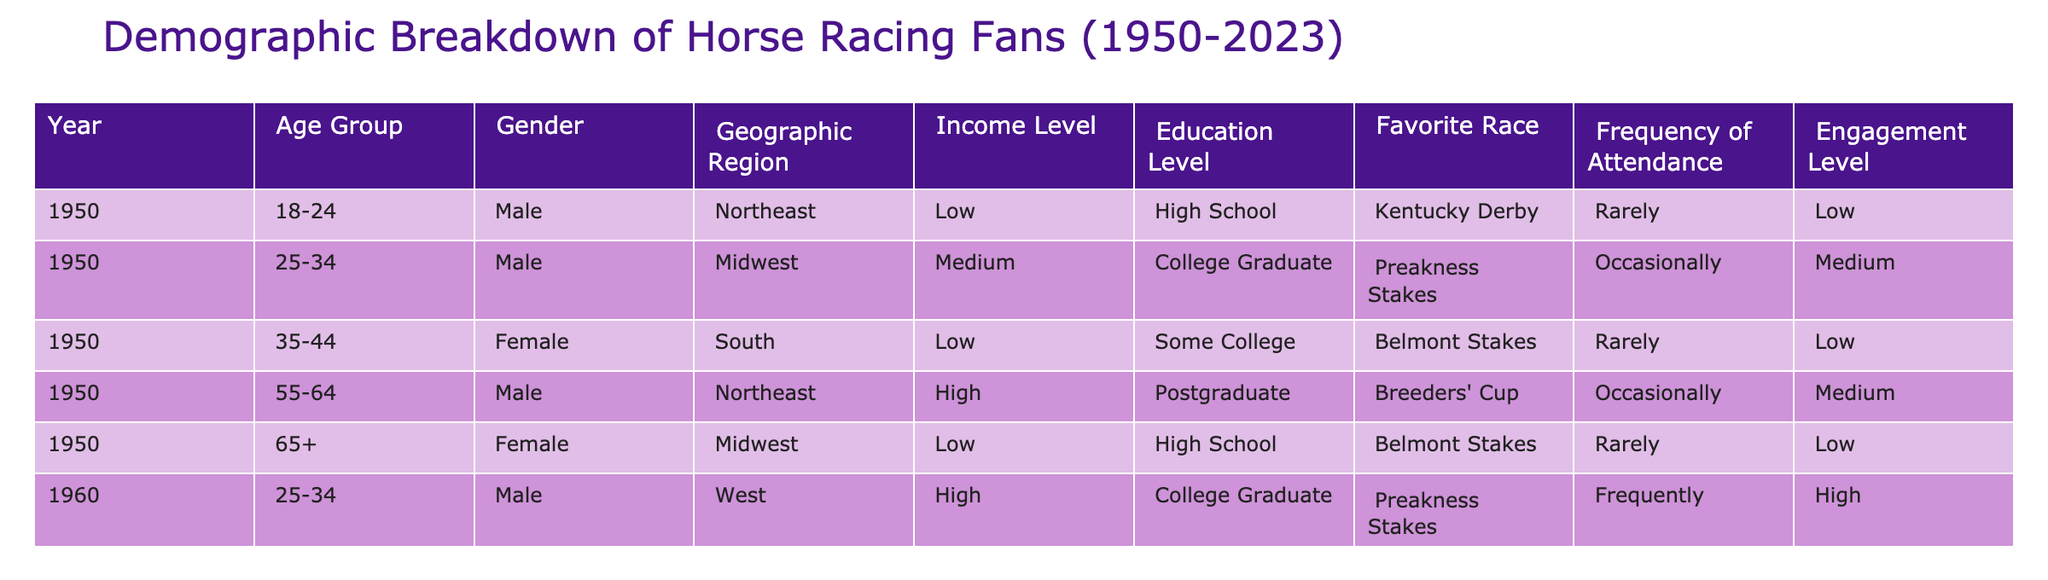What was the favorite race for fans aged 18-24 in 1950? Referring to the table, in the year 1950 for the age group 18-24, the favorite race is the Kentucky Derby.
Answer: Kentucky Derby How many female fans were there in 1950? The table lists two entries for females in 1950: one in the age group 35-44 and the other 65+. Therefore, there are two female fans.
Answer: 2 What percentage of fans in 1950 had a college education or higher? In 1950, there are two individuals with a college education (one with a College Graduate status and one with a Postgraduate status) out of a total of five fans. (2/5) * 100 = 40%.
Answer: 40% Which geographic region had the highest engagement level among fans aged 25-34 in 1960? In the year 1960, for the age group 25-34, the only entry is male from the West who has a high engagement level, thus this region has the highest engagement level.
Answer: West What is the difference in income levels between the youngest and oldest age groups in 1950? In 1950, the age group 18-24 had a low income level, while the 65+ age group also had a low income level. The difference in their income levels is 0 as both are classified as low.
Answer: 0 Did any female fan in 1950 prefer the Preakness Stakes? Looking at the data for 1950, all female fans preferred either the Belmont Stakes or Breeders' Cup and not the Preakness Stakes, hence the answer is no.
Answer: No What was the frequency of attendance for fans with a postgraduate education in 1950? In 1950, the only fan with a postgraduate education belonged to the age group 55-64 and had an attendance frequency of Occasionally.
Answer: Occasionally What is the average age of fans from the Northeast region in 1950? The ages for fans in the Northeast region in 1950 are 18-24 and 55-64. To find the average, we convert these ranges to values: 21 (midpoint of 18-24) and 59.5 (midpoint of 55-64). So, the average age is (21 + 59.5) / 2 = 40.75.
Answer: 40.75 In 1960, what was the engagement level for fans from the West? In 1960, the only entry from the West is a male in the age group 25-34 with a high engagement level. Thus, the engagement level for fans from the West is high.
Answer: High How many fans had a favorite race of the Belmont Stakes across all years? In 1950, there were two entries for the Belmont Stakes (one female in the age group 35-44 and one female in the 65+ category). Therefore, there are a total of two fans who preferred the Belmont Stakes.
Answer: 2 